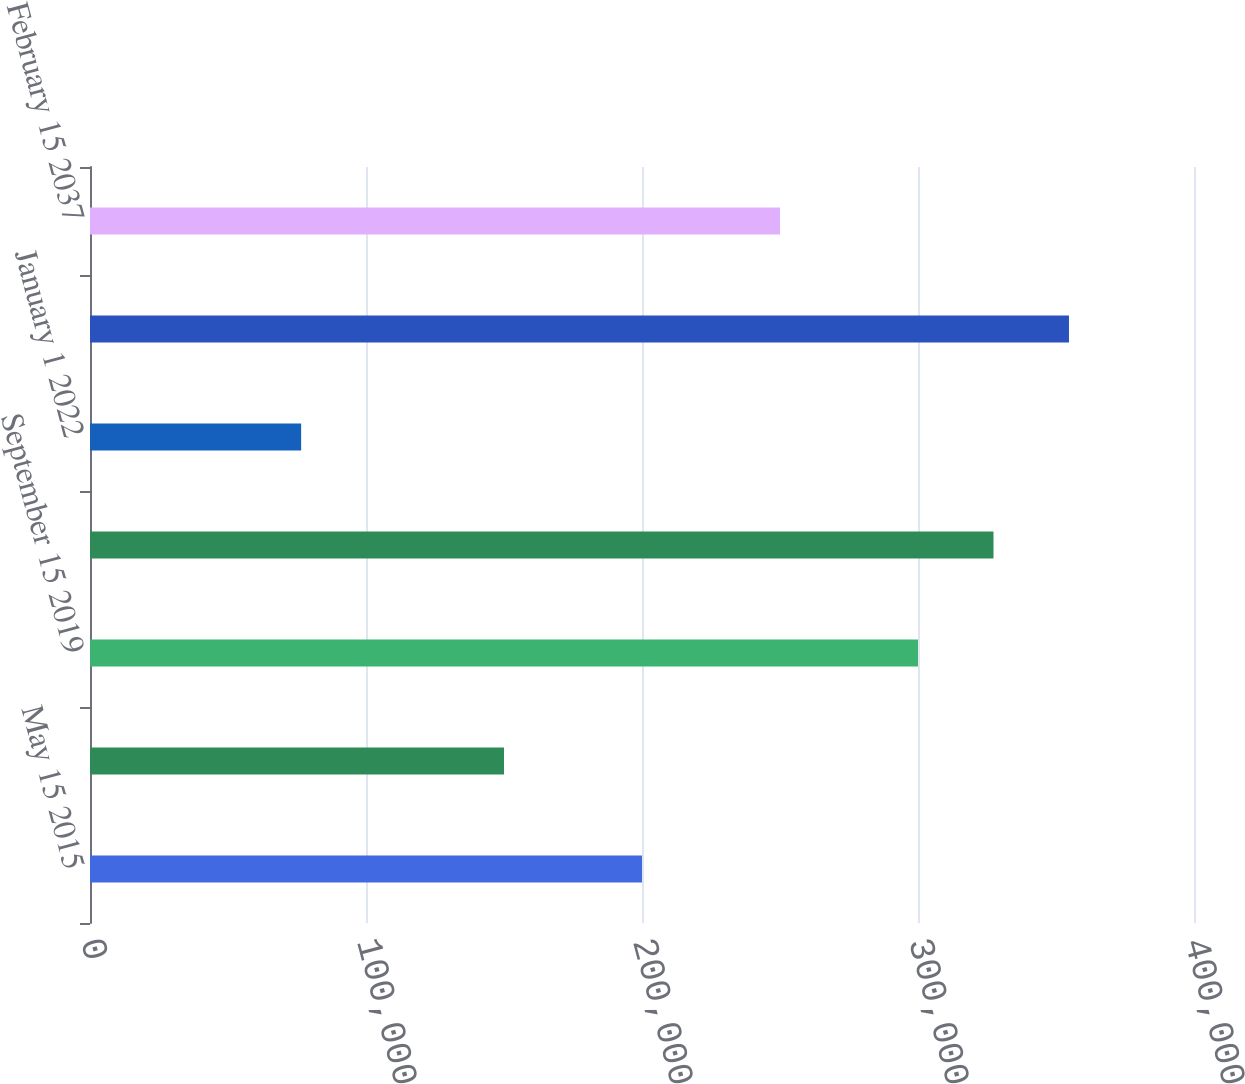Convert chart to OTSL. <chart><loc_0><loc_0><loc_500><loc_500><bar_chart><fcel>May 15 2015<fcel>August 15 2019<fcel>September 15 2019<fcel>September 15 2020<fcel>January 1 2022<fcel>March 15 2022<fcel>February 15 2037<nl><fcel>200000<fcel>150000<fcel>300000<fcel>327350<fcel>76503<fcel>354699<fcel>250000<nl></chart> 